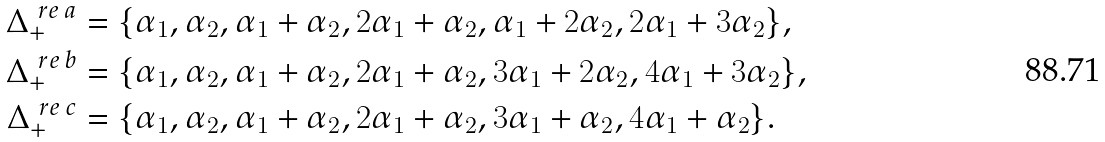Convert formula to latex. <formula><loc_0><loc_0><loc_500><loc_500>\Delta ^ { \ r e \, a } _ { + } & = \{ \alpha _ { 1 } , \alpha _ { 2 } , \alpha _ { 1 } + \alpha _ { 2 } , 2 \alpha _ { 1 } + \alpha _ { 2 } , \alpha _ { 1 } + 2 \alpha _ { 2 } , 2 \alpha _ { 1 } + 3 \alpha _ { 2 } \} , \\ \Delta ^ { \ r e \, b } _ { + } & = \{ \alpha _ { 1 } , \alpha _ { 2 } , \alpha _ { 1 } + \alpha _ { 2 } , 2 \alpha _ { 1 } + \alpha _ { 2 } , 3 \alpha _ { 1 } + 2 \alpha _ { 2 } , 4 \alpha _ { 1 } + 3 \alpha _ { 2 } \} , \\ \Delta ^ { \ r e \, c } _ { + } & = \{ \alpha _ { 1 } , \alpha _ { 2 } , \alpha _ { 1 } + \alpha _ { 2 } , 2 \alpha _ { 1 } + \alpha _ { 2 } , 3 \alpha _ { 1 } + \alpha _ { 2 } , 4 \alpha _ { 1 } + \alpha _ { 2 } \} .</formula> 